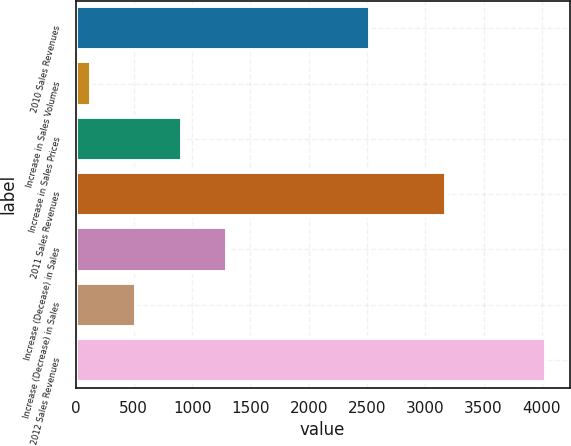Convert chart to OTSL. <chart><loc_0><loc_0><loc_500><loc_500><bar_chart><fcel>2010 Sales Revenues<fcel>Increase in Sales Volumes<fcel>Increase in Sales Prices<fcel>2011 Sales Revenues<fcel>Increase (Decease) in Sales<fcel>Increase (Decrease) in Sales<fcel>2012 Sales Revenues<nl><fcel>2523<fcel>131<fcel>912.2<fcel>3179<fcel>1302.8<fcel>521.6<fcel>4037<nl></chart> 